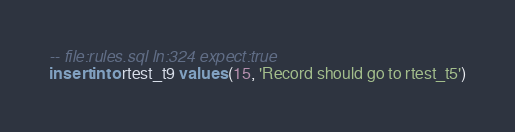<code> <loc_0><loc_0><loc_500><loc_500><_SQL_>-- file:rules.sql ln:324 expect:true
insert into rtest_t9 values (15, 'Record should go to rtest_t5')
</code> 